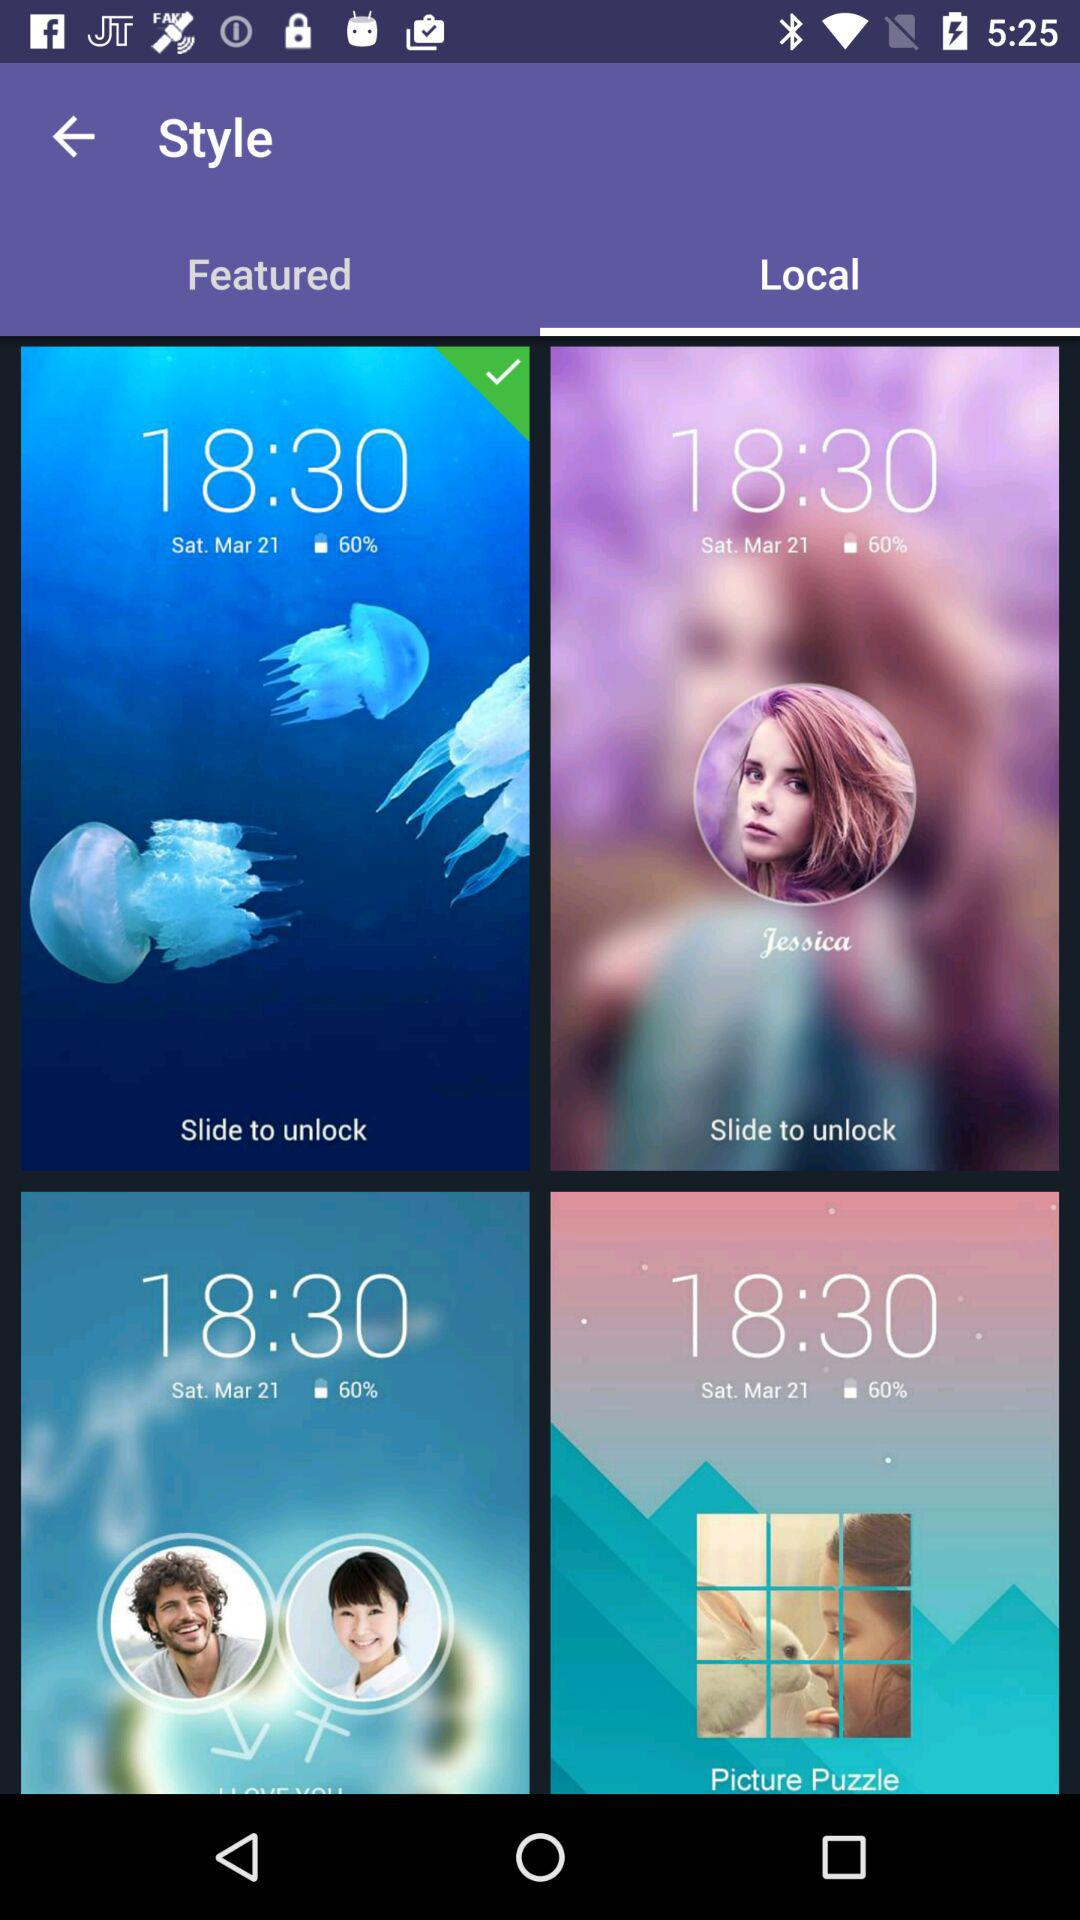Which tab is selected? The selected tab is "Local". 